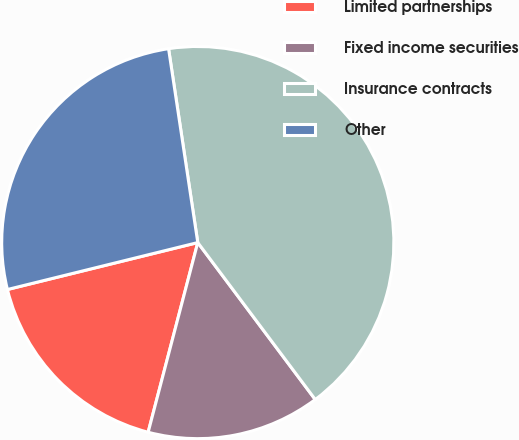<chart> <loc_0><loc_0><loc_500><loc_500><pie_chart><fcel>Limited partnerships<fcel>Fixed income securities<fcel>Insurance contracts<fcel>Other<nl><fcel>17.08%<fcel>14.3%<fcel>42.16%<fcel>26.47%<nl></chart> 